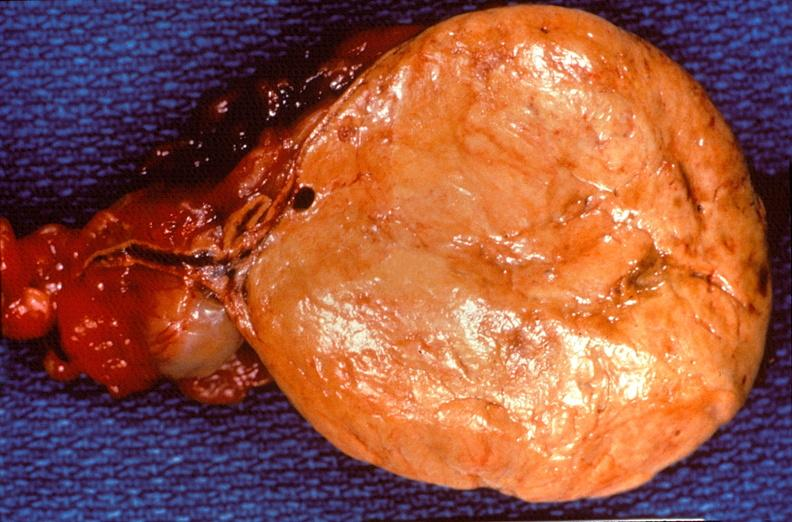s muscle atrophy present?
Answer the question using a single word or phrase. No 